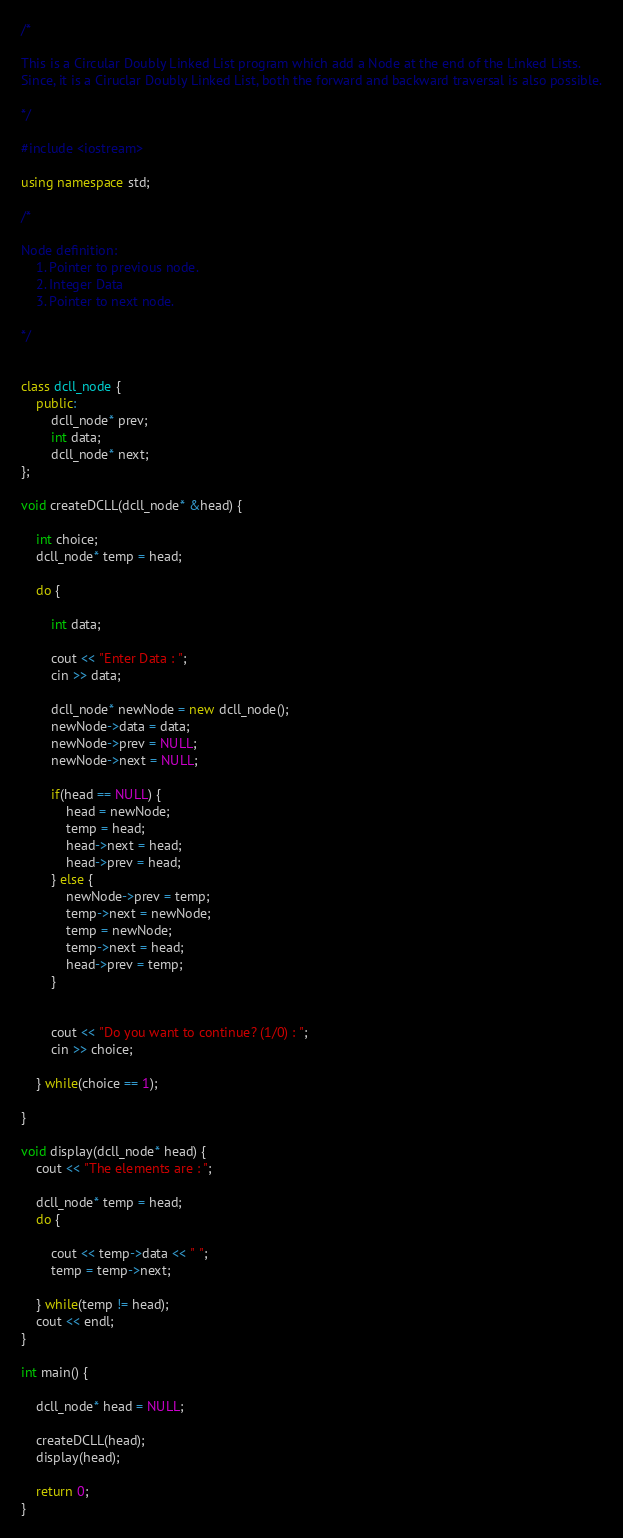<code> <loc_0><loc_0><loc_500><loc_500><_C++_>/*

This is a Circular Doubly Linked List program which add a Node at the end of the Linked Lists.
Since, it is a Ciruclar Doubly Linked List, both the forward and backward traversal is also possible.

*/

#include <iostream>

using namespace std;

/*

Node definition:
	1. Pointer to previous node.
	2. Integer Data
	3. Pointer to next node.

*/


class dcll_node {
	public:
		dcll_node* prev;
		int data;
		dcll_node* next;
};

void createDCLL(dcll_node* &head) {

	int choice;
	dcll_node* temp = head;

	do {

		int data;

		cout << "Enter Data : ";
		cin >> data;

		dcll_node* newNode = new dcll_node();
		newNode->data = data;
		newNode->prev = NULL;
		newNode->next = NULL;

		if(head == NULL) {
			head = newNode;
			temp = head;
			head->next = head;
			head->prev = head;
		} else {
			newNode->prev = temp;
			temp->next = newNode;
			temp = newNode;
			temp->next = head;
			head->prev = temp;
		}


		cout << "Do you want to continue? (1/0) : ";
		cin >> choice;

	} while(choice == 1);

}

void display(dcll_node* head) {
	cout << "The elements are : ";

	dcll_node* temp = head;
	do {

		cout << temp->data << " ";
		temp = temp->next;

	} while(temp != head);
	cout << endl;
}

int main() {

	dcll_node* head = NULL;

	createDCLL(head);
	display(head);

	return 0;
}</code> 